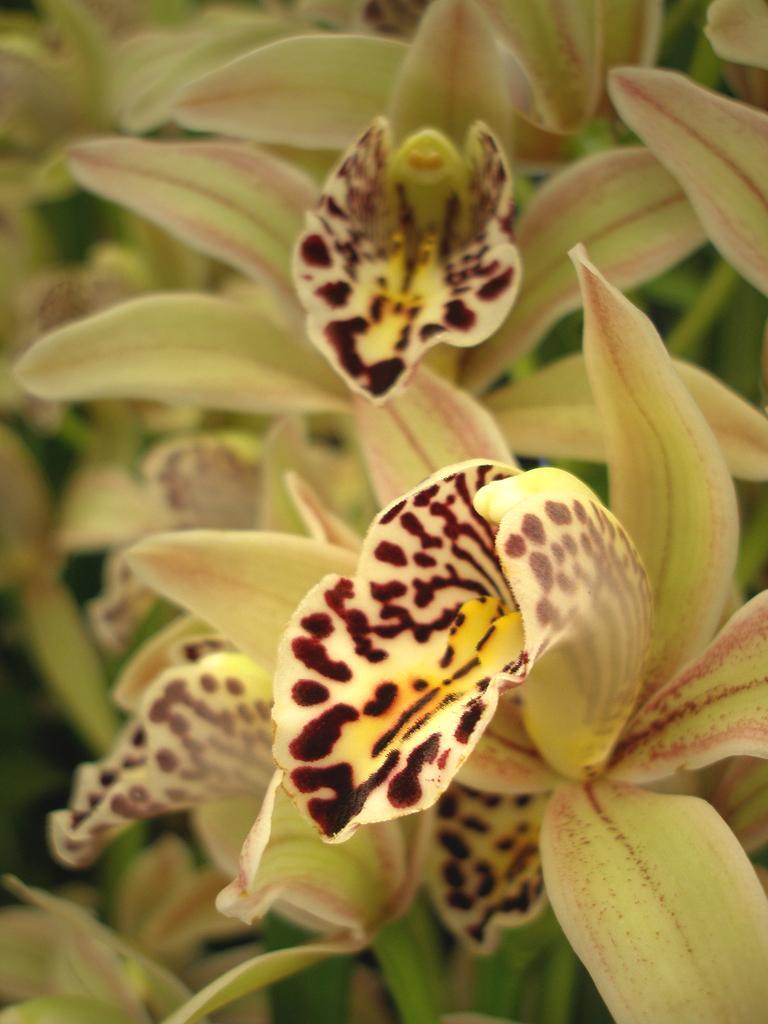Can you describe this image briefly? In this image we can see flowers. 